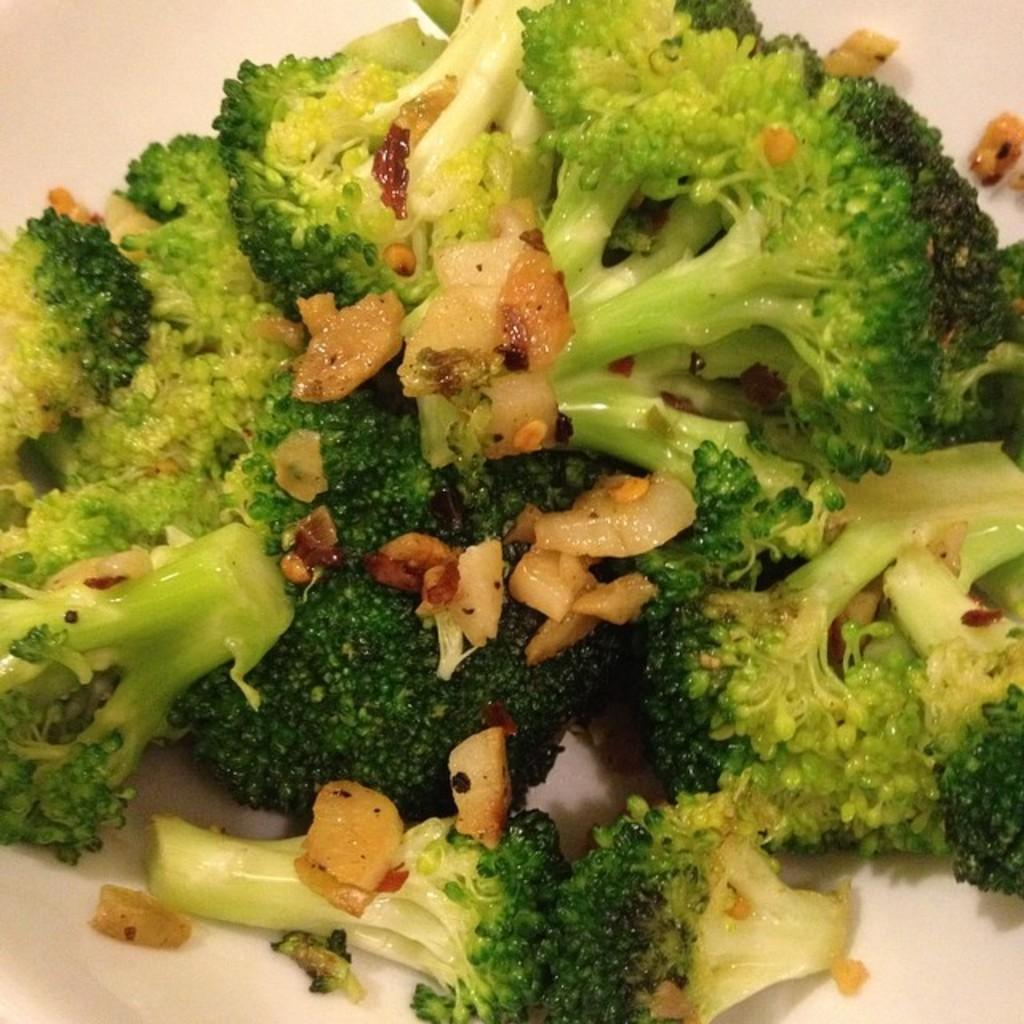What type of vegetable is present in the image? There is broccoli in the image. What else can be seen in the image besides the broccoli? There are other objects in the image. On what surface are the objects placed? The objects are placed on a white surface. Where is the yam located in the image? There is no yam present in the image. On what type of furniture are the objects placed in the image? The provided facts do not mention any furniture, only a white surface. 